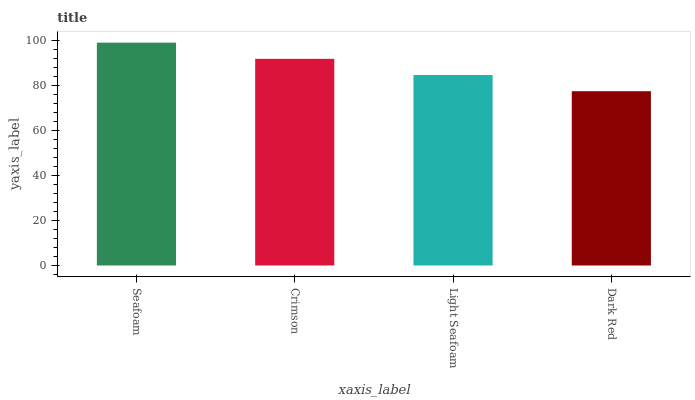Is Crimson the minimum?
Answer yes or no. No. Is Crimson the maximum?
Answer yes or no. No. Is Seafoam greater than Crimson?
Answer yes or no. Yes. Is Crimson less than Seafoam?
Answer yes or no. Yes. Is Crimson greater than Seafoam?
Answer yes or no. No. Is Seafoam less than Crimson?
Answer yes or no. No. Is Crimson the high median?
Answer yes or no. Yes. Is Light Seafoam the low median?
Answer yes or no. Yes. Is Light Seafoam the high median?
Answer yes or no. No. Is Crimson the low median?
Answer yes or no. No. 